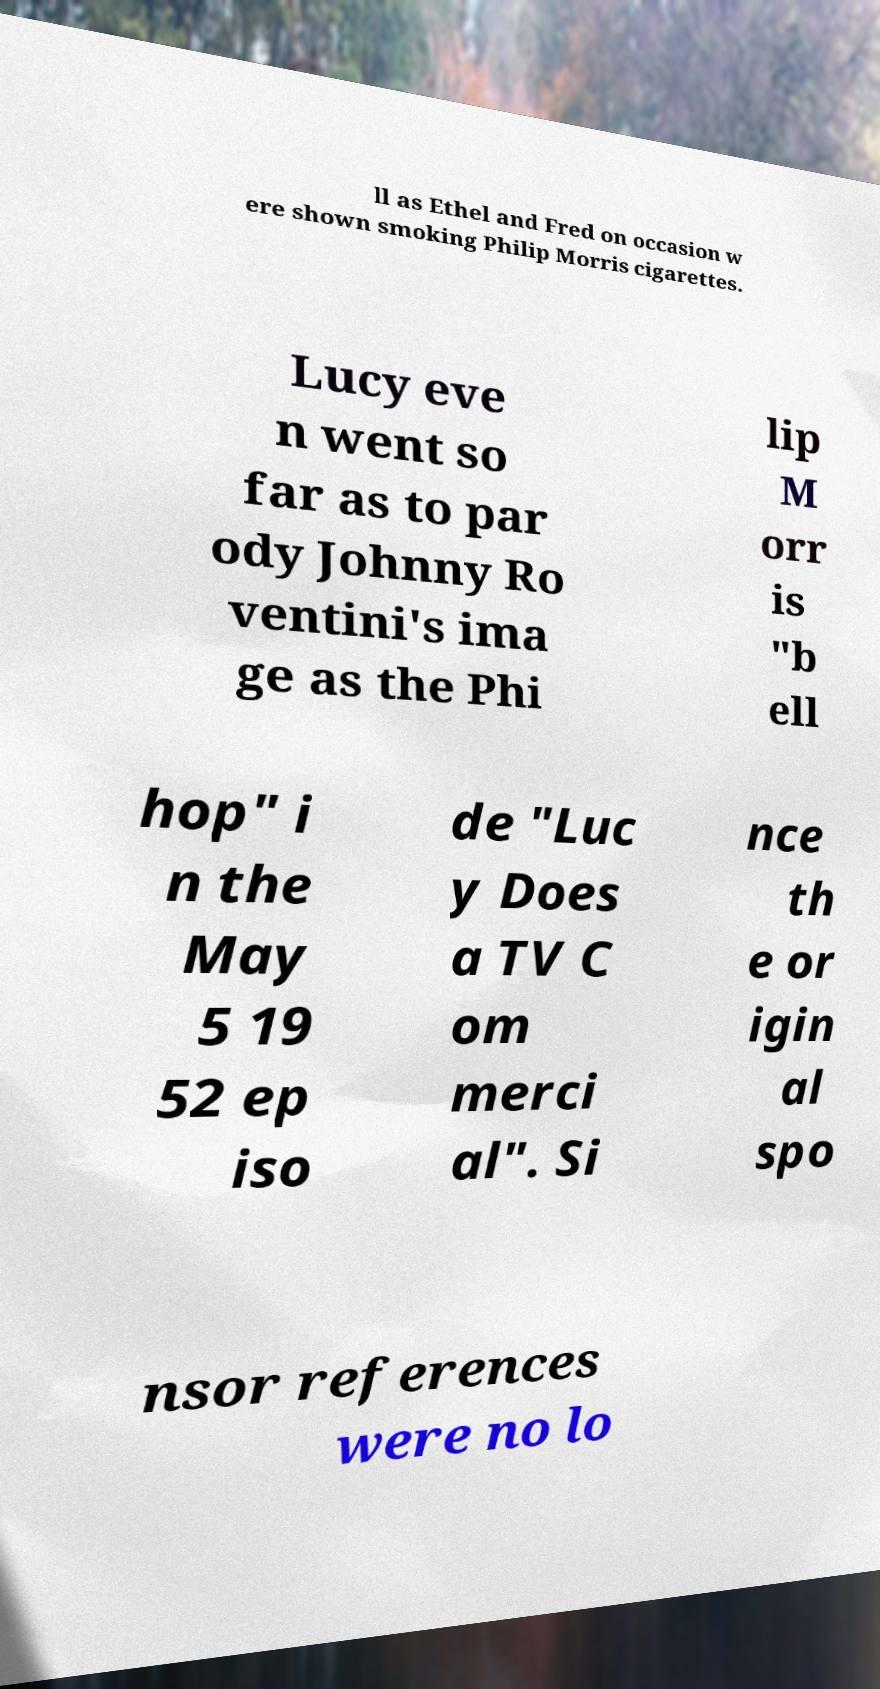I need the written content from this picture converted into text. Can you do that? ll as Ethel and Fred on occasion w ere shown smoking Philip Morris cigarettes. Lucy eve n went so far as to par ody Johnny Ro ventini's ima ge as the Phi lip M orr is "b ell hop" i n the May 5 19 52 ep iso de "Luc y Does a TV C om merci al". Si nce th e or igin al spo nsor references were no lo 